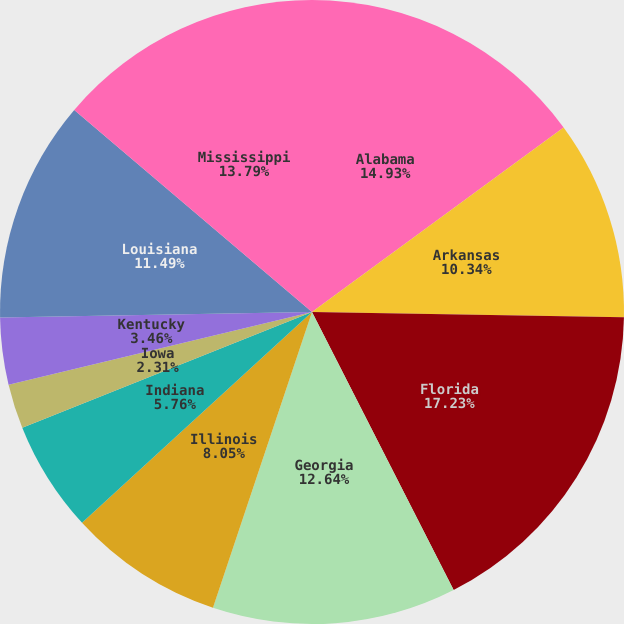Convert chart to OTSL. <chart><loc_0><loc_0><loc_500><loc_500><pie_chart><fcel>Alabama<fcel>Arkansas<fcel>Florida<fcel>Georgia<fcel>Illinois<fcel>Indiana<fcel>Iowa<fcel>Kentucky<fcel>Louisiana<fcel>Mississippi<nl><fcel>14.93%<fcel>10.34%<fcel>17.23%<fcel>12.64%<fcel>8.05%<fcel>5.76%<fcel>2.31%<fcel>3.46%<fcel>11.49%<fcel>13.79%<nl></chart> 